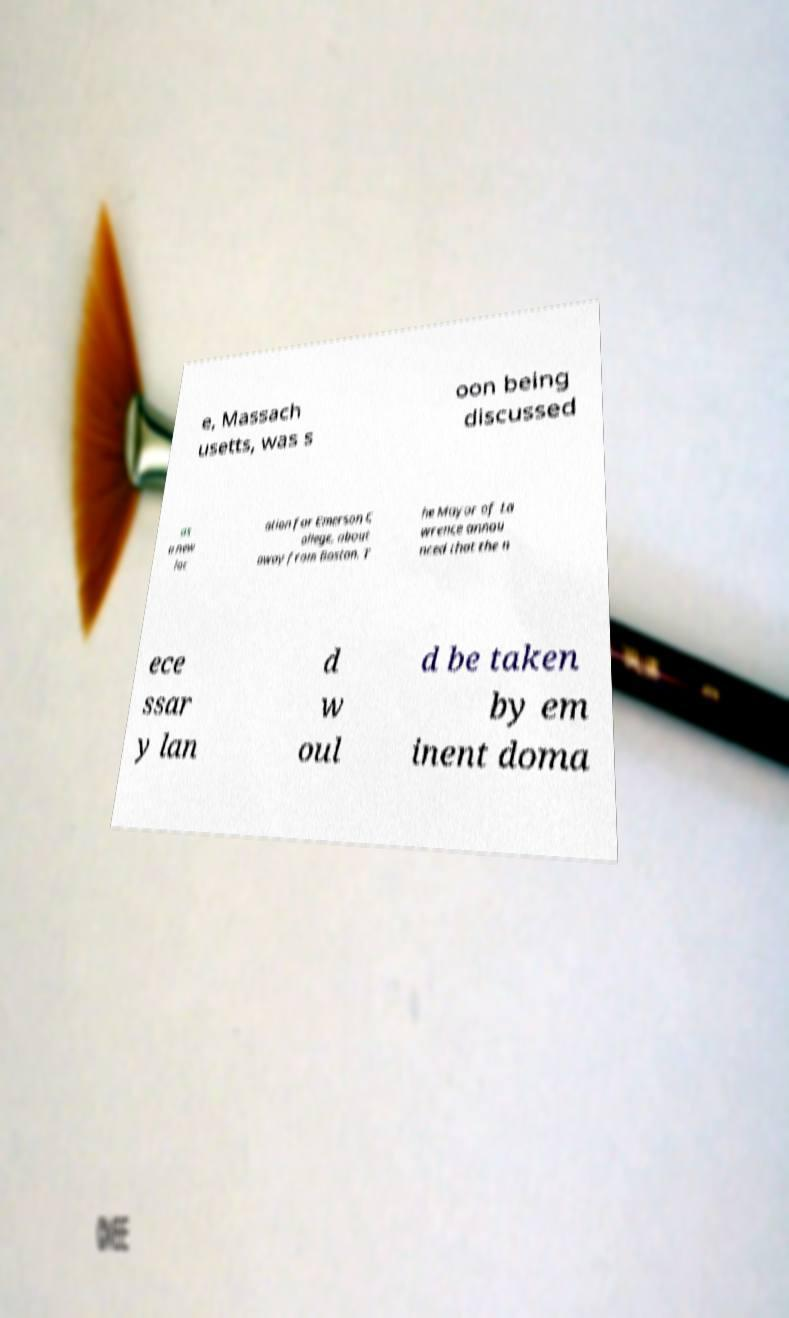Please read and relay the text visible in this image. What does it say? e, Massach usetts, was s oon being discussed as a new loc ation for Emerson C ollege, about away from Boston. T he Mayor of La wrence annou nced that the n ece ssar y lan d w oul d be taken by em inent doma 